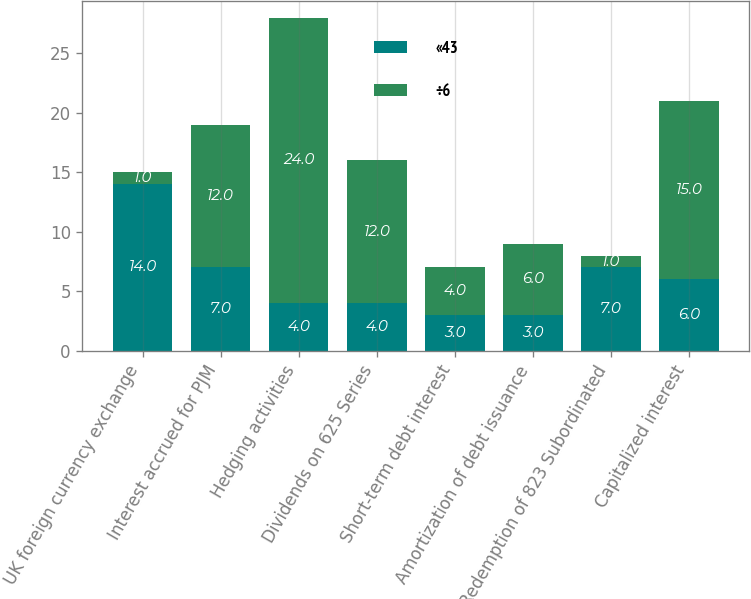Convert chart to OTSL. <chart><loc_0><loc_0><loc_500><loc_500><stacked_bar_chart><ecel><fcel>UK foreign currency exchange<fcel>Interest accrued for PJM<fcel>Hedging activities<fcel>Dividends on 625 Series<fcel>Short-term debt interest<fcel>Amortization of debt issuance<fcel>Redemption of 823 Subordinated<fcel>Capitalized interest<nl><fcel>«43<fcel>14<fcel>7<fcel>4<fcel>4<fcel>3<fcel>3<fcel>7<fcel>6<nl><fcel>÷6<fcel>1<fcel>12<fcel>24<fcel>12<fcel>4<fcel>6<fcel>1<fcel>15<nl></chart> 